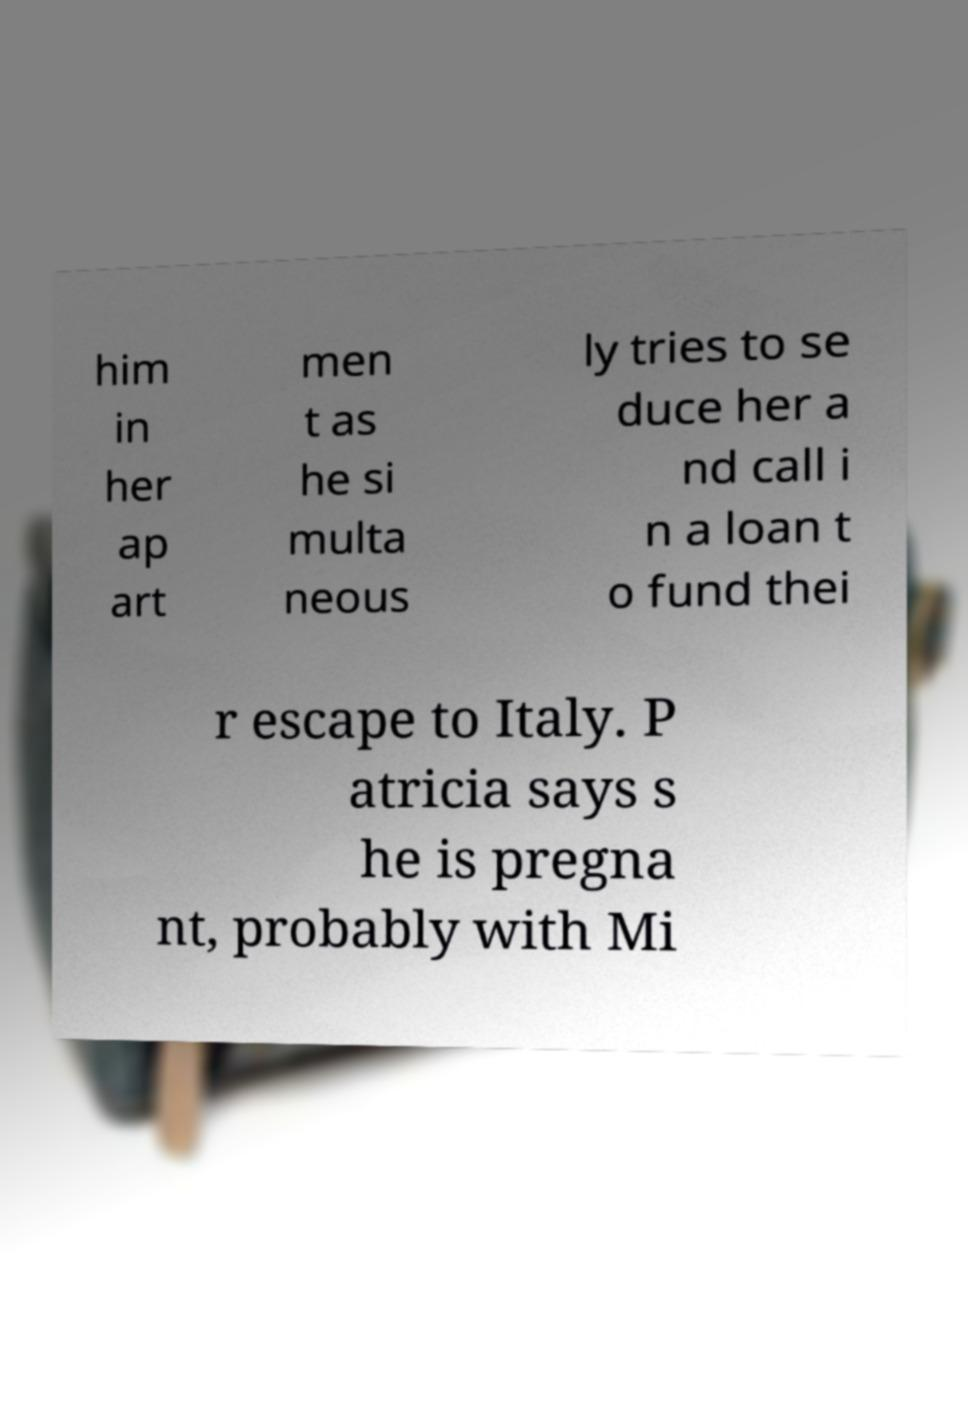Can you read and provide the text displayed in the image?This photo seems to have some interesting text. Can you extract and type it out for me? him in her ap art men t as he si multa neous ly tries to se duce her a nd call i n a loan t o fund thei r escape to Italy. P atricia says s he is pregna nt, probably with Mi 